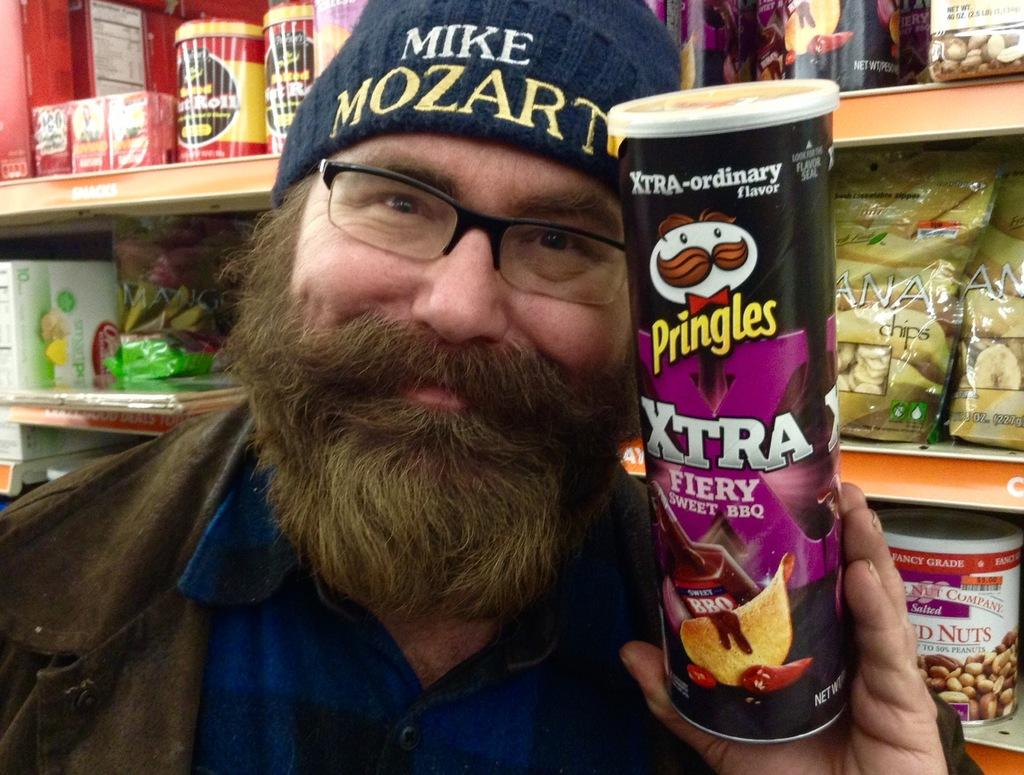What is the man in the image doing? The man is standing in the image and holding a box. What is the man holding in the image? The man is holding a box. What can be seen in the background of the image? There are shelves in the background of the image. What items are on the shelves? There are packets and bottles on the shelves. What type of government is depicted in the image? There is no depiction of a government in the image; it features a man holding a box and shelves with packets and bottles. Can you tell me how many squares are present in the image? There is no square present in the image. 